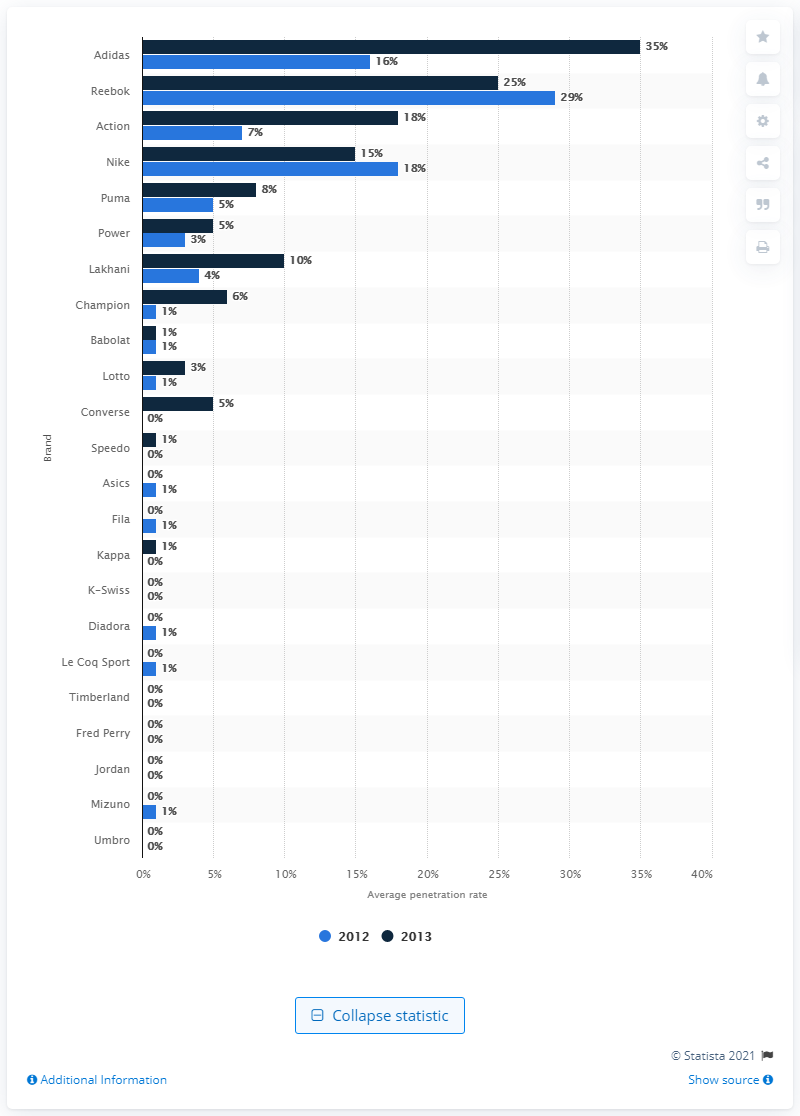Draw attention to some important aspects in this diagram. In a survey conducted in 2013, 15% of respondents reported purchasing Nike sportswear in the last three to twelve months. 